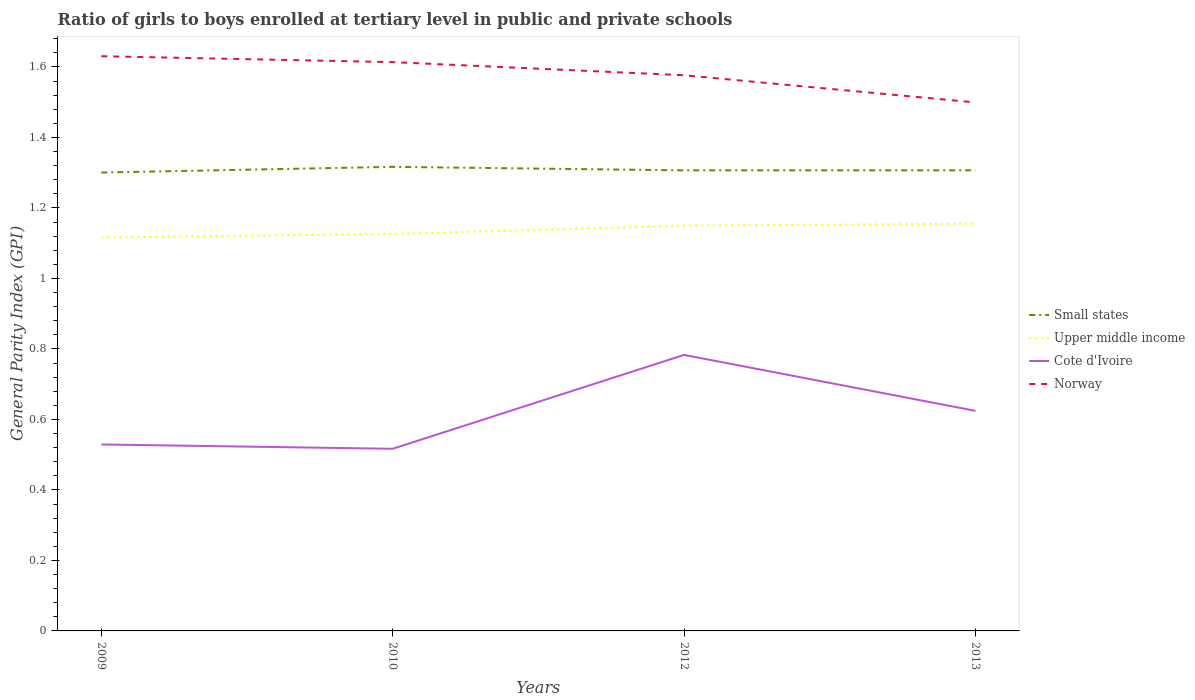Does the line corresponding to Small states intersect with the line corresponding to Norway?
Offer a very short reply. No. Across all years, what is the maximum general parity index in Cote d'Ivoire?
Your answer should be compact. 0.52. What is the total general parity index in Upper middle income in the graph?
Your response must be concise. -0.01. What is the difference between the highest and the second highest general parity index in Norway?
Ensure brevity in your answer.  0.13. Does the graph contain any zero values?
Offer a very short reply. No. Does the graph contain grids?
Provide a short and direct response. No. Where does the legend appear in the graph?
Give a very brief answer. Center right. How are the legend labels stacked?
Ensure brevity in your answer.  Vertical. What is the title of the graph?
Provide a succinct answer. Ratio of girls to boys enrolled at tertiary level in public and private schools. Does "Djibouti" appear as one of the legend labels in the graph?
Make the answer very short. No. What is the label or title of the Y-axis?
Ensure brevity in your answer.  General Parity Index (GPI). What is the General Parity Index (GPI) of Small states in 2009?
Give a very brief answer. 1.3. What is the General Parity Index (GPI) of Upper middle income in 2009?
Give a very brief answer. 1.12. What is the General Parity Index (GPI) of Cote d'Ivoire in 2009?
Offer a very short reply. 0.53. What is the General Parity Index (GPI) in Norway in 2009?
Your answer should be compact. 1.63. What is the General Parity Index (GPI) of Small states in 2010?
Ensure brevity in your answer.  1.32. What is the General Parity Index (GPI) in Upper middle income in 2010?
Give a very brief answer. 1.13. What is the General Parity Index (GPI) of Cote d'Ivoire in 2010?
Ensure brevity in your answer.  0.52. What is the General Parity Index (GPI) in Norway in 2010?
Ensure brevity in your answer.  1.61. What is the General Parity Index (GPI) in Small states in 2012?
Your answer should be compact. 1.31. What is the General Parity Index (GPI) of Upper middle income in 2012?
Make the answer very short. 1.15. What is the General Parity Index (GPI) in Cote d'Ivoire in 2012?
Ensure brevity in your answer.  0.78. What is the General Parity Index (GPI) of Norway in 2012?
Offer a terse response. 1.58. What is the General Parity Index (GPI) of Small states in 2013?
Your response must be concise. 1.31. What is the General Parity Index (GPI) in Upper middle income in 2013?
Give a very brief answer. 1.16. What is the General Parity Index (GPI) in Cote d'Ivoire in 2013?
Provide a succinct answer. 0.62. What is the General Parity Index (GPI) of Norway in 2013?
Offer a very short reply. 1.5. Across all years, what is the maximum General Parity Index (GPI) in Small states?
Give a very brief answer. 1.32. Across all years, what is the maximum General Parity Index (GPI) of Upper middle income?
Offer a very short reply. 1.16. Across all years, what is the maximum General Parity Index (GPI) of Cote d'Ivoire?
Your response must be concise. 0.78. Across all years, what is the maximum General Parity Index (GPI) of Norway?
Your answer should be very brief. 1.63. Across all years, what is the minimum General Parity Index (GPI) in Small states?
Give a very brief answer. 1.3. Across all years, what is the minimum General Parity Index (GPI) in Upper middle income?
Provide a succinct answer. 1.12. Across all years, what is the minimum General Parity Index (GPI) in Cote d'Ivoire?
Provide a succinct answer. 0.52. Across all years, what is the minimum General Parity Index (GPI) in Norway?
Your response must be concise. 1.5. What is the total General Parity Index (GPI) in Small states in the graph?
Give a very brief answer. 5.23. What is the total General Parity Index (GPI) of Upper middle income in the graph?
Your response must be concise. 4.55. What is the total General Parity Index (GPI) in Cote d'Ivoire in the graph?
Your answer should be compact. 2.45. What is the total General Parity Index (GPI) of Norway in the graph?
Offer a very short reply. 6.32. What is the difference between the General Parity Index (GPI) in Small states in 2009 and that in 2010?
Offer a terse response. -0.02. What is the difference between the General Parity Index (GPI) in Upper middle income in 2009 and that in 2010?
Give a very brief answer. -0.01. What is the difference between the General Parity Index (GPI) of Cote d'Ivoire in 2009 and that in 2010?
Keep it short and to the point. 0.01. What is the difference between the General Parity Index (GPI) of Norway in 2009 and that in 2010?
Your answer should be compact. 0.02. What is the difference between the General Parity Index (GPI) of Small states in 2009 and that in 2012?
Provide a short and direct response. -0.01. What is the difference between the General Parity Index (GPI) in Upper middle income in 2009 and that in 2012?
Offer a terse response. -0.03. What is the difference between the General Parity Index (GPI) in Cote d'Ivoire in 2009 and that in 2012?
Keep it short and to the point. -0.25. What is the difference between the General Parity Index (GPI) in Norway in 2009 and that in 2012?
Ensure brevity in your answer.  0.05. What is the difference between the General Parity Index (GPI) in Small states in 2009 and that in 2013?
Ensure brevity in your answer.  -0.01. What is the difference between the General Parity Index (GPI) in Upper middle income in 2009 and that in 2013?
Ensure brevity in your answer.  -0.04. What is the difference between the General Parity Index (GPI) of Cote d'Ivoire in 2009 and that in 2013?
Your response must be concise. -0.1. What is the difference between the General Parity Index (GPI) in Norway in 2009 and that in 2013?
Give a very brief answer. 0.13. What is the difference between the General Parity Index (GPI) in Upper middle income in 2010 and that in 2012?
Your answer should be compact. -0.02. What is the difference between the General Parity Index (GPI) of Cote d'Ivoire in 2010 and that in 2012?
Your response must be concise. -0.27. What is the difference between the General Parity Index (GPI) of Norway in 2010 and that in 2012?
Provide a short and direct response. 0.04. What is the difference between the General Parity Index (GPI) in Small states in 2010 and that in 2013?
Your response must be concise. 0.01. What is the difference between the General Parity Index (GPI) in Upper middle income in 2010 and that in 2013?
Ensure brevity in your answer.  -0.03. What is the difference between the General Parity Index (GPI) in Cote d'Ivoire in 2010 and that in 2013?
Ensure brevity in your answer.  -0.11. What is the difference between the General Parity Index (GPI) of Norway in 2010 and that in 2013?
Provide a succinct answer. 0.11. What is the difference between the General Parity Index (GPI) of Small states in 2012 and that in 2013?
Offer a terse response. -0. What is the difference between the General Parity Index (GPI) in Upper middle income in 2012 and that in 2013?
Ensure brevity in your answer.  -0.01. What is the difference between the General Parity Index (GPI) of Cote d'Ivoire in 2012 and that in 2013?
Keep it short and to the point. 0.16. What is the difference between the General Parity Index (GPI) of Norway in 2012 and that in 2013?
Provide a short and direct response. 0.08. What is the difference between the General Parity Index (GPI) of Small states in 2009 and the General Parity Index (GPI) of Upper middle income in 2010?
Offer a very short reply. 0.17. What is the difference between the General Parity Index (GPI) of Small states in 2009 and the General Parity Index (GPI) of Cote d'Ivoire in 2010?
Offer a terse response. 0.78. What is the difference between the General Parity Index (GPI) of Small states in 2009 and the General Parity Index (GPI) of Norway in 2010?
Your answer should be very brief. -0.31. What is the difference between the General Parity Index (GPI) in Upper middle income in 2009 and the General Parity Index (GPI) in Cote d'Ivoire in 2010?
Offer a very short reply. 0.6. What is the difference between the General Parity Index (GPI) in Upper middle income in 2009 and the General Parity Index (GPI) in Norway in 2010?
Offer a very short reply. -0.5. What is the difference between the General Parity Index (GPI) in Cote d'Ivoire in 2009 and the General Parity Index (GPI) in Norway in 2010?
Offer a terse response. -1.08. What is the difference between the General Parity Index (GPI) of Small states in 2009 and the General Parity Index (GPI) of Upper middle income in 2012?
Your answer should be compact. 0.15. What is the difference between the General Parity Index (GPI) of Small states in 2009 and the General Parity Index (GPI) of Cote d'Ivoire in 2012?
Ensure brevity in your answer.  0.52. What is the difference between the General Parity Index (GPI) of Small states in 2009 and the General Parity Index (GPI) of Norway in 2012?
Offer a very short reply. -0.28. What is the difference between the General Parity Index (GPI) of Upper middle income in 2009 and the General Parity Index (GPI) of Cote d'Ivoire in 2012?
Offer a terse response. 0.33. What is the difference between the General Parity Index (GPI) in Upper middle income in 2009 and the General Parity Index (GPI) in Norway in 2012?
Provide a succinct answer. -0.46. What is the difference between the General Parity Index (GPI) of Cote d'Ivoire in 2009 and the General Parity Index (GPI) of Norway in 2012?
Offer a terse response. -1.05. What is the difference between the General Parity Index (GPI) of Small states in 2009 and the General Parity Index (GPI) of Upper middle income in 2013?
Give a very brief answer. 0.14. What is the difference between the General Parity Index (GPI) in Small states in 2009 and the General Parity Index (GPI) in Cote d'Ivoire in 2013?
Provide a short and direct response. 0.68. What is the difference between the General Parity Index (GPI) in Small states in 2009 and the General Parity Index (GPI) in Norway in 2013?
Offer a terse response. -0.2. What is the difference between the General Parity Index (GPI) of Upper middle income in 2009 and the General Parity Index (GPI) of Cote d'Ivoire in 2013?
Offer a terse response. 0.49. What is the difference between the General Parity Index (GPI) in Upper middle income in 2009 and the General Parity Index (GPI) in Norway in 2013?
Your answer should be very brief. -0.38. What is the difference between the General Parity Index (GPI) of Cote d'Ivoire in 2009 and the General Parity Index (GPI) of Norway in 2013?
Offer a terse response. -0.97. What is the difference between the General Parity Index (GPI) in Small states in 2010 and the General Parity Index (GPI) in Upper middle income in 2012?
Keep it short and to the point. 0.17. What is the difference between the General Parity Index (GPI) of Small states in 2010 and the General Parity Index (GPI) of Cote d'Ivoire in 2012?
Your answer should be compact. 0.53. What is the difference between the General Parity Index (GPI) in Small states in 2010 and the General Parity Index (GPI) in Norway in 2012?
Your response must be concise. -0.26. What is the difference between the General Parity Index (GPI) of Upper middle income in 2010 and the General Parity Index (GPI) of Cote d'Ivoire in 2012?
Give a very brief answer. 0.34. What is the difference between the General Parity Index (GPI) of Upper middle income in 2010 and the General Parity Index (GPI) of Norway in 2012?
Provide a succinct answer. -0.45. What is the difference between the General Parity Index (GPI) in Cote d'Ivoire in 2010 and the General Parity Index (GPI) in Norway in 2012?
Provide a succinct answer. -1.06. What is the difference between the General Parity Index (GPI) in Small states in 2010 and the General Parity Index (GPI) in Upper middle income in 2013?
Provide a succinct answer. 0.16. What is the difference between the General Parity Index (GPI) in Small states in 2010 and the General Parity Index (GPI) in Cote d'Ivoire in 2013?
Your answer should be very brief. 0.69. What is the difference between the General Parity Index (GPI) in Small states in 2010 and the General Parity Index (GPI) in Norway in 2013?
Offer a very short reply. -0.18. What is the difference between the General Parity Index (GPI) of Upper middle income in 2010 and the General Parity Index (GPI) of Cote d'Ivoire in 2013?
Make the answer very short. 0.5. What is the difference between the General Parity Index (GPI) in Upper middle income in 2010 and the General Parity Index (GPI) in Norway in 2013?
Your response must be concise. -0.37. What is the difference between the General Parity Index (GPI) of Cote d'Ivoire in 2010 and the General Parity Index (GPI) of Norway in 2013?
Offer a terse response. -0.98. What is the difference between the General Parity Index (GPI) in Small states in 2012 and the General Parity Index (GPI) in Upper middle income in 2013?
Keep it short and to the point. 0.15. What is the difference between the General Parity Index (GPI) of Small states in 2012 and the General Parity Index (GPI) of Cote d'Ivoire in 2013?
Provide a short and direct response. 0.68. What is the difference between the General Parity Index (GPI) of Small states in 2012 and the General Parity Index (GPI) of Norway in 2013?
Your answer should be compact. -0.19. What is the difference between the General Parity Index (GPI) of Upper middle income in 2012 and the General Parity Index (GPI) of Cote d'Ivoire in 2013?
Your answer should be very brief. 0.53. What is the difference between the General Parity Index (GPI) in Upper middle income in 2012 and the General Parity Index (GPI) in Norway in 2013?
Your answer should be very brief. -0.35. What is the difference between the General Parity Index (GPI) of Cote d'Ivoire in 2012 and the General Parity Index (GPI) of Norway in 2013?
Provide a short and direct response. -0.72. What is the average General Parity Index (GPI) in Small states per year?
Provide a short and direct response. 1.31. What is the average General Parity Index (GPI) in Upper middle income per year?
Offer a terse response. 1.14. What is the average General Parity Index (GPI) in Cote d'Ivoire per year?
Provide a short and direct response. 0.61. What is the average General Parity Index (GPI) in Norway per year?
Offer a terse response. 1.58. In the year 2009, what is the difference between the General Parity Index (GPI) of Small states and General Parity Index (GPI) of Upper middle income?
Your answer should be very brief. 0.18. In the year 2009, what is the difference between the General Parity Index (GPI) of Small states and General Parity Index (GPI) of Cote d'Ivoire?
Make the answer very short. 0.77. In the year 2009, what is the difference between the General Parity Index (GPI) in Small states and General Parity Index (GPI) in Norway?
Provide a short and direct response. -0.33. In the year 2009, what is the difference between the General Parity Index (GPI) in Upper middle income and General Parity Index (GPI) in Cote d'Ivoire?
Make the answer very short. 0.59. In the year 2009, what is the difference between the General Parity Index (GPI) in Upper middle income and General Parity Index (GPI) in Norway?
Your response must be concise. -0.51. In the year 2009, what is the difference between the General Parity Index (GPI) in Cote d'Ivoire and General Parity Index (GPI) in Norway?
Give a very brief answer. -1.1. In the year 2010, what is the difference between the General Parity Index (GPI) of Small states and General Parity Index (GPI) of Upper middle income?
Make the answer very short. 0.19. In the year 2010, what is the difference between the General Parity Index (GPI) in Small states and General Parity Index (GPI) in Cote d'Ivoire?
Your answer should be compact. 0.8. In the year 2010, what is the difference between the General Parity Index (GPI) in Small states and General Parity Index (GPI) in Norway?
Keep it short and to the point. -0.3. In the year 2010, what is the difference between the General Parity Index (GPI) in Upper middle income and General Parity Index (GPI) in Cote d'Ivoire?
Your response must be concise. 0.61. In the year 2010, what is the difference between the General Parity Index (GPI) of Upper middle income and General Parity Index (GPI) of Norway?
Make the answer very short. -0.49. In the year 2010, what is the difference between the General Parity Index (GPI) in Cote d'Ivoire and General Parity Index (GPI) in Norway?
Keep it short and to the point. -1.1. In the year 2012, what is the difference between the General Parity Index (GPI) of Small states and General Parity Index (GPI) of Upper middle income?
Your answer should be very brief. 0.16. In the year 2012, what is the difference between the General Parity Index (GPI) of Small states and General Parity Index (GPI) of Cote d'Ivoire?
Your answer should be very brief. 0.52. In the year 2012, what is the difference between the General Parity Index (GPI) of Small states and General Parity Index (GPI) of Norway?
Make the answer very short. -0.27. In the year 2012, what is the difference between the General Parity Index (GPI) in Upper middle income and General Parity Index (GPI) in Cote d'Ivoire?
Provide a succinct answer. 0.37. In the year 2012, what is the difference between the General Parity Index (GPI) of Upper middle income and General Parity Index (GPI) of Norway?
Offer a terse response. -0.43. In the year 2012, what is the difference between the General Parity Index (GPI) of Cote d'Ivoire and General Parity Index (GPI) of Norway?
Provide a short and direct response. -0.79. In the year 2013, what is the difference between the General Parity Index (GPI) of Small states and General Parity Index (GPI) of Upper middle income?
Give a very brief answer. 0.15. In the year 2013, what is the difference between the General Parity Index (GPI) in Small states and General Parity Index (GPI) in Cote d'Ivoire?
Offer a terse response. 0.68. In the year 2013, what is the difference between the General Parity Index (GPI) of Small states and General Parity Index (GPI) of Norway?
Keep it short and to the point. -0.19. In the year 2013, what is the difference between the General Parity Index (GPI) in Upper middle income and General Parity Index (GPI) in Cote d'Ivoire?
Ensure brevity in your answer.  0.53. In the year 2013, what is the difference between the General Parity Index (GPI) in Upper middle income and General Parity Index (GPI) in Norway?
Your answer should be very brief. -0.34. In the year 2013, what is the difference between the General Parity Index (GPI) in Cote d'Ivoire and General Parity Index (GPI) in Norway?
Your response must be concise. -0.87. What is the ratio of the General Parity Index (GPI) of Small states in 2009 to that in 2010?
Make the answer very short. 0.99. What is the ratio of the General Parity Index (GPI) of Cote d'Ivoire in 2009 to that in 2010?
Give a very brief answer. 1.02. What is the ratio of the General Parity Index (GPI) of Norway in 2009 to that in 2010?
Your response must be concise. 1.01. What is the ratio of the General Parity Index (GPI) in Upper middle income in 2009 to that in 2012?
Your answer should be compact. 0.97. What is the ratio of the General Parity Index (GPI) in Cote d'Ivoire in 2009 to that in 2012?
Offer a terse response. 0.68. What is the ratio of the General Parity Index (GPI) in Norway in 2009 to that in 2012?
Offer a terse response. 1.03. What is the ratio of the General Parity Index (GPI) in Small states in 2009 to that in 2013?
Ensure brevity in your answer.  1. What is the ratio of the General Parity Index (GPI) in Cote d'Ivoire in 2009 to that in 2013?
Give a very brief answer. 0.85. What is the ratio of the General Parity Index (GPI) of Norway in 2009 to that in 2013?
Offer a terse response. 1.09. What is the ratio of the General Parity Index (GPI) of Small states in 2010 to that in 2012?
Offer a very short reply. 1.01. What is the ratio of the General Parity Index (GPI) of Upper middle income in 2010 to that in 2012?
Make the answer very short. 0.98. What is the ratio of the General Parity Index (GPI) of Cote d'Ivoire in 2010 to that in 2012?
Offer a terse response. 0.66. What is the ratio of the General Parity Index (GPI) of Norway in 2010 to that in 2012?
Your answer should be compact. 1.02. What is the ratio of the General Parity Index (GPI) of Small states in 2010 to that in 2013?
Your answer should be very brief. 1.01. What is the ratio of the General Parity Index (GPI) of Upper middle income in 2010 to that in 2013?
Ensure brevity in your answer.  0.97. What is the ratio of the General Parity Index (GPI) of Cote d'Ivoire in 2010 to that in 2013?
Your response must be concise. 0.83. What is the ratio of the General Parity Index (GPI) of Norway in 2010 to that in 2013?
Offer a terse response. 1.08. What is the ratio of the General Parity Index (GPI) of Cote d'Ivoire in 2012 to that in 2013?
Offer a terse response. 1.25. What is the ratio of the General Parity Index (GPI) of Norway in 2012 to that in 2013?
Your response must be concise. 1.05. What is the difference between the highest and the second highest General Parity Index (GPI) of Small states?
Ensure brevity in your answer.  0.01. What is the difference between the highest and the second highest General Parity Index (GPI) in Upper middle income?
Your answer should be compact. 0.01. What is the difference between the highest and the second highest General Parity Index (GPI) in Cote d'Ivoire?
Your answer should be compact. 0.16. What is the difference between the highest and the second highest General Parity Index (GPI) in Norway?
Ensure brevity in your answer.  0.02. What is the difference between the highest and the lowest General Parity Index (GPI) of Small states?
Keep it short and to the point. 0.02. What is the difference between the highest and the lowest General Parity Index (GPI) in Upper middle income?
Your answer should be compact. 0.04. What is the difference between the highest and the lowest General Parity Index (GPI) of Cote d'Ivoire?
Keep it short and to the point. 0.27. What is the difference between the highest and the lowest General Parity Index (GPI) in Norway?
Offer a terse response. 0.13. 